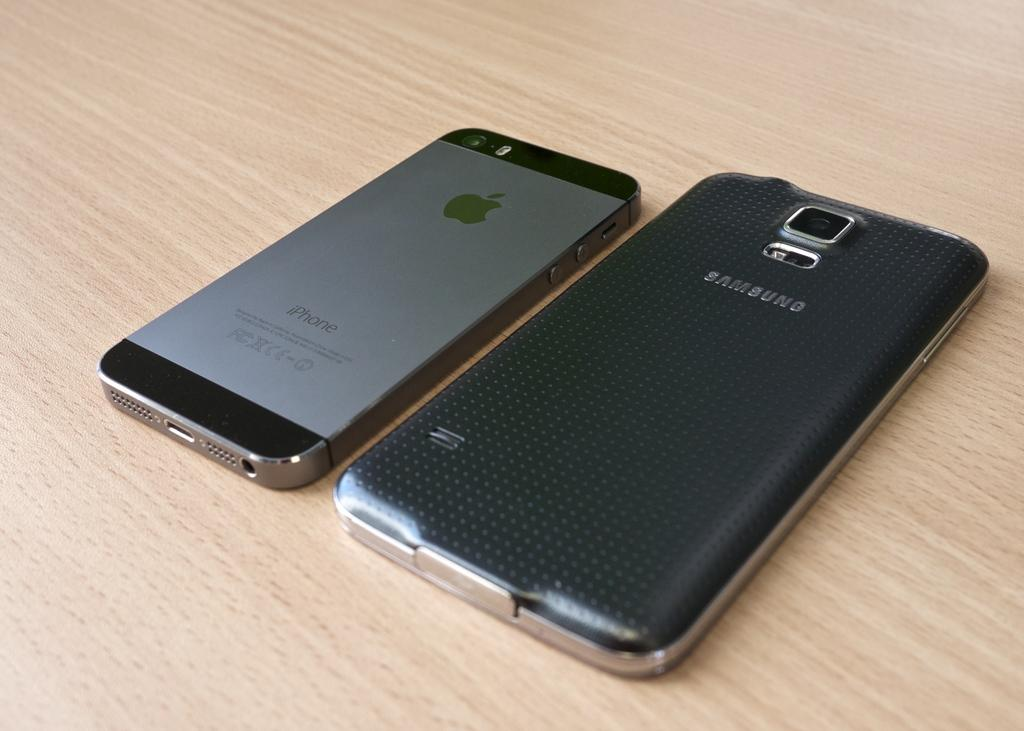Provide a one-sentence caption for the provided image. A Samsung phone and an Apple iPhone are laying on a wood surface. 